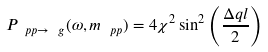Convert formula to latex. <formula><loc_0><loc_0><loc_500><loc_500>P _ { \ p p \to \ g } ( \omega , m _ { \ p p } ) = 4 \chi ^ { 2 } \sin ^ { 2 } \left ( \frac { \Delta q l } { 2 } \right )</formula> 